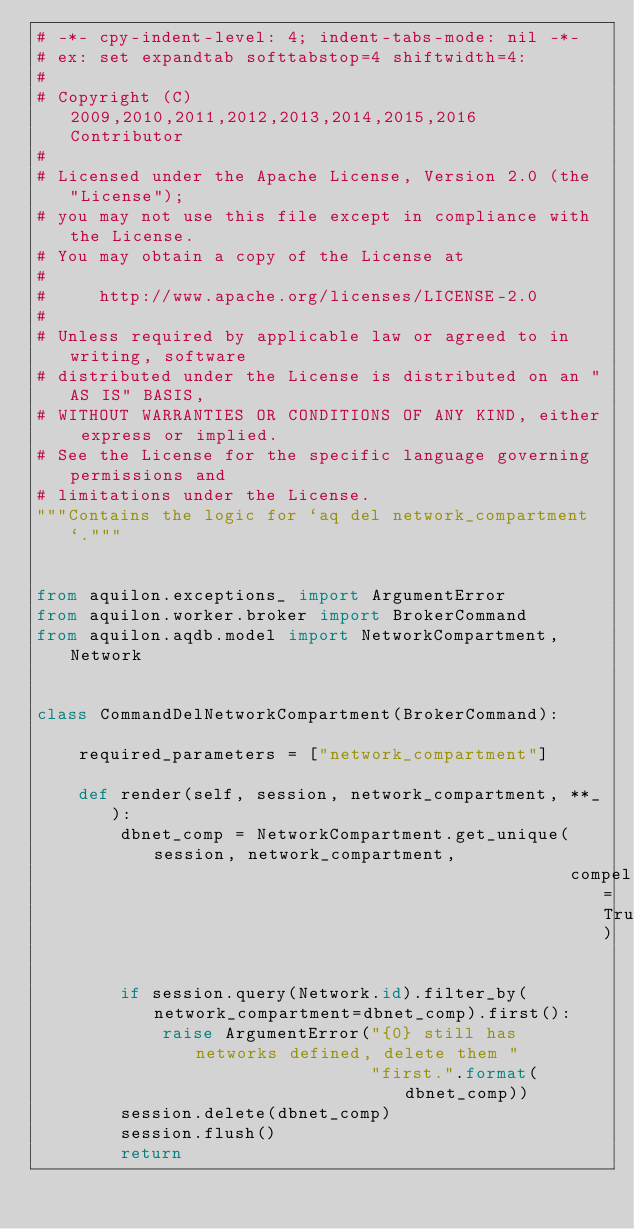<code> <loc_0><loc_0><loc_500><loc_500><_Python_># -*- cpy-indent-level: 4; indent-tabs-mode: nil -*-
# ex: set expandtab softtabstop=4 shiftwidth=4:
#
# Copyright (C) 2009,2010,2011,2012,2013,2014,2015,2016  Contributor
#
# Licensed under the Apache License, Version 2.0 (the "License");
# you may not use this file except in compliance with the License.
# You may obtain a copy of the License at
#
#     http://www.apache.org/licenses/LICENSE-2.0
#
# Unless required by applicable law or agreed to in writing, software
# distributed under the License is distributed on an "AS IS" BASIS,
# WITHOUT WARRANTIES OR CONDITIONS OF ANY KIND, either express or implied.
# See the License for the specific language governing permissions and
# limitations under the License.
"""Contains the logic for `aq del network_compartment`."""


from aquilon.exceptions_ import ArgumentError
from aquilon.worker.broker import BrokerCommand
from aquilon.aqdb.model import NetworkCompartment, Network


class CommandDelNetworkCompartment(BrokerCommand):

    required_parameters = ["network_compartment"]

    def render(self, session, network_compartment, **_):
        dbnet_comp = NetworkCompartment.get_unique(session, network_compartment,
                                                   compel=True)

        if session.query(Network.id).filter_by(network_compartment=dbnet_comp).first():
            raise ArgumentError("{0} still has networks defined, delete them "
                                "first.".format(dbnet_comp))
        session.delete(dbnet_comp)
        session.flush()
        return
</code> 